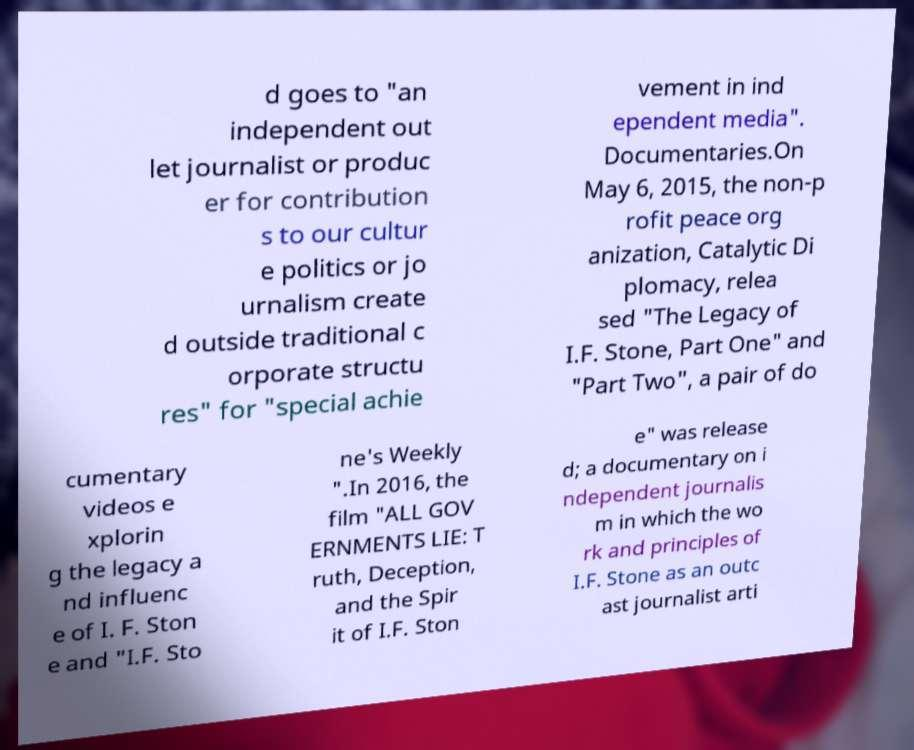There's text embedded in this image that I need extracted. Can you transcribe it verbatim? d goes to "an independent out let journalist or produc er for contribution s to our cultur e politics or jo urnalism create d outside traditional c orporate structu res" for "special achie vement in ind ependent media". Documentaries.On May 6, 2015, the non-p rofit peace org anization, Catalytic Di plomacy, relea sed "The Legacy of I.F. Stone, Part One" and "Part Two", a pair of do cumentary videos e xplorin g the legacy a nd influenc e of I. F. Ston e and "I.F. Sto ne's Weekly ".In 2016, the film "ALL GOV ERNMENTS LIE: T ruth, Deception, and the Spir it of I.F. Ston e" was release d; a documentary on i ndependent journalis m in which the wo rk and principles of I.F. Stone as an outc ast journalist arti 